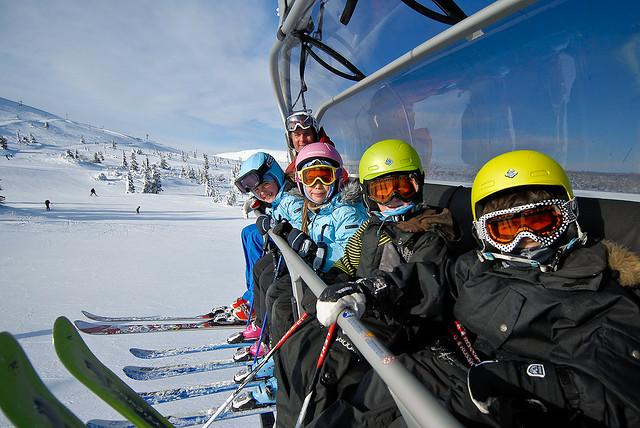Which course are the people on the lift probably being brought to? Please explain your reasoning. beginner. The people are quite young. 